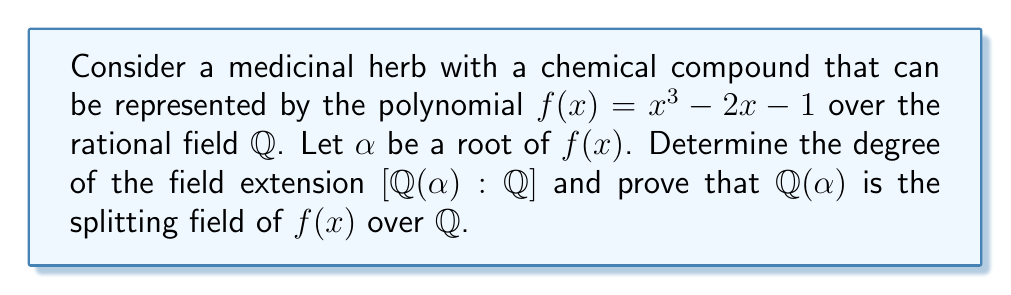Show me your answer to this math problem. 1) First, we need to determine if $f(x)$ is irreducible over $\mathbb{Q}$. We can use Eisenstein's criterion with $p=2$:
   - The leading coefficient is 1, which is not divisible by 2.
   - All other coefficients (-2 and -1) are divisible by 2.
   - The constant term -1 is not divisible by $2^2 = 4$.
   Therefore, $f(x)$ is irreducible over $\mathbb{Q}$.

2) Since $f(x)$ is irreducible and $\alpha$ is a root, the degree of the extension is equal to the degree of $f(x)$:
   $[\mathbb{Q}(\alpha) : \mathbb{Q}] = 3$

3) To prove that $\mathbb{Q}(\alpha)$ is the splitting field, we need to show that all roots of $f(x)$ are in $\mathbb{Q}(\alpha)$.

4) Let $\beta$ and $\gamma$ be the other two roots of $f(x)$. We know that:
   $\alpha + \beta + \gamma = 0$ (sum of roots)
   $\alpha\beta + \beta\gamma + \gamma\alpha = -2$ (sum of products of roots taken two at a time)
   $\alpha\beta\gamma = 1$ (negative of the constant term)

5) From these relations, we can express $\beta$ and $\gamma$ in terms of $\alpha$:
   $\beta + \gamma = -\alpha$
   $\beta\gamma = \frac{-2 - \alpha(-\alpha)}{-\alpha} = \frac{-2 + \alpha^2}{\alpha}$

6) Using the quadratic formula, we can express $\beta$ and $\gamma$ as:
   $$\beta, \gamma = \frac{-(-\alpha) \pm \sqrt{(-\alpha)^2 - 4(\frac{-2 + \alpha^2}{\alpha})}}{2}$$
   $$= \frac{\alpha \pm \sqrt{\alpha^2 - 4(\frac{-2 + \alpha^2}{\alpha})}}{2}$$
   $$= \frac{\alpha \pm \sqrt{\frac{\alpha^3 + 8 - 4\alpha^2}{\alpha}}}{2}$$
   $$= \frac{\alpha \pm \sqrt{\frac{2\alpha + 1}{\alpha}}}{2}$$ (using $\alpha^3 = 2\alpha + 1$)

7) This shows that $\beta$ and $\gamma$ are in $\mathbb{Q}(\alpha)$, as they can be expressed using $\alpha$ and elements from $\mathbb{Q}$.

Therefore, $\mathbb{Q}(\alpha)$ contains all roots of $f(x)$ and is indeed the splitting field.
Answer: $[\mathbb{Q}(\alpha) : \mathbb{Q}] = 3$, and $\mathbb{Q}(\alpha)$ is the splitting field of $f(x)$ over $\mathbb{Q}$. 